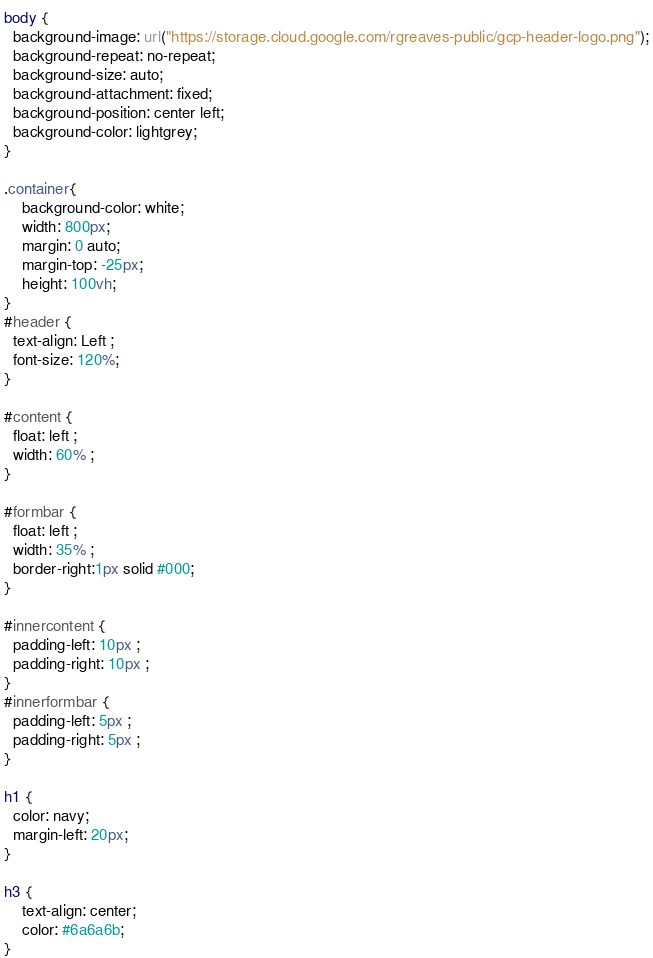Convert code to text. <code><loc_0><loc_0><loc_500><loc_500><_CSS_>body {
  background-image: url("https://storage.cloud.google.com/rgreaves-public/gcp-header-logo.png");
  background-repeat: no-repeat;
  background-size: auto;
  background-attachment: fixed;
  background-position: center left;
  background-color: lightgrey;
}

.container{
    background-color: white;
    width: 800px;
    margin: 0 auto;
    margin-top: -25px;
    height: 100vh;
}
#header {
  text-align: Left ;
  font-size: 120%;
}

#content {
  float: left ;
  width: 60% ;
}

#formbar {
  float: left ;
  width: 35% ;
  border-right:1px solid #000;
}

#innercontent {
  padding-left: 10px ;
  padding-right: 10px ;
}
#innerformbar {
  padding-left: 5px ;
  padding-right: 5px ;
}

h1 {
  color: navy;
  margin-left: 20px;
}

h3 {
    text-align: center;
    color: #6a6a6b;
}
</code> 